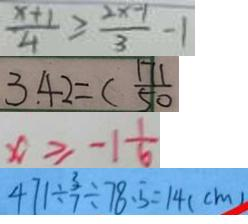<formula> <loc_0><loc_0><loc_500><loc_500>\frac { x + 1 } { 4 } \geq \frac { 2 x - 1 } { 3 } - 1 
 3 . 4 2 = ( \frac { 1 7 1 } { 5 0 } 
 x \geq - 1 \frac { 1 } { 6 } 
 4 7 1 \div \frac { 3 } { 7 } \div 7 8 . 5 = 1 4 ( c m )</formula> 